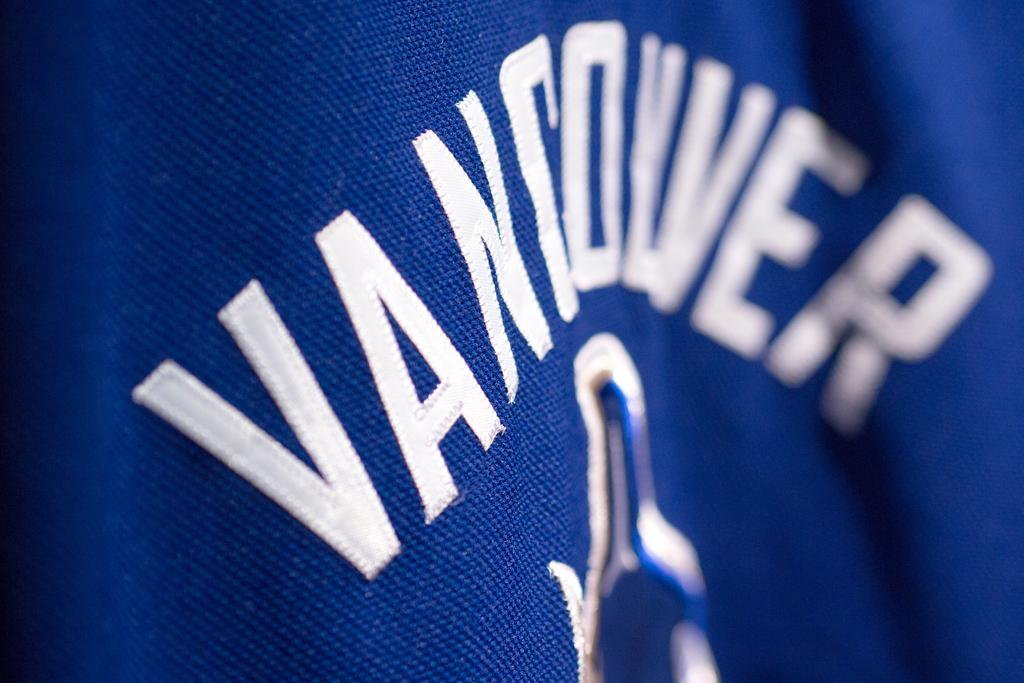What type of clothing is visible in the image? There is a blue color t-shirt in the image. What is featured on the t-shirt? There is something printed on the t-shirt. What type of vest is visible in the image? There is no vest present in the image; it only features a blue t-shirt. What type of flower is printed on the t-shirt? There is no flower printed on the t-shirt; the image only mentions that there is something printed on it without specifying the design. 